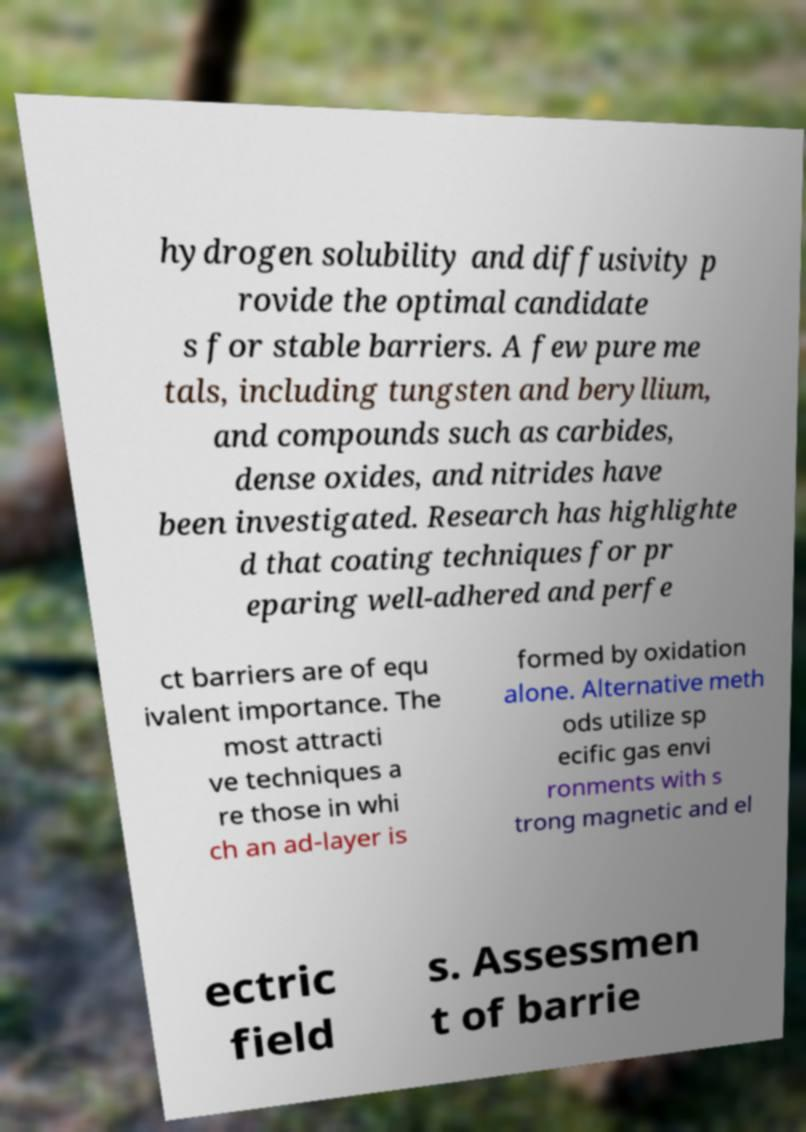I need the written content from this picture converted into text. Can you do that? hydrogen solubility and diffusivity p rovide the optimal candidate s for stable barriers. A few pure me tals, including tungsten and beryllium, and compounds such as carbides, dense oxides, and nitrides have been investigated. Research has highlighte d that coating techniques for pr eparing well-adhered and perfe ct barriers are of equ ivalent importance. The most attracti ve techniques a re those in whi ch an ad-layer is formed by oxidation alone. Alternative meth ods utilize sp ecific gas envi ronments with s trong magnetic and el ectric field s. Assessmen t of barrie 